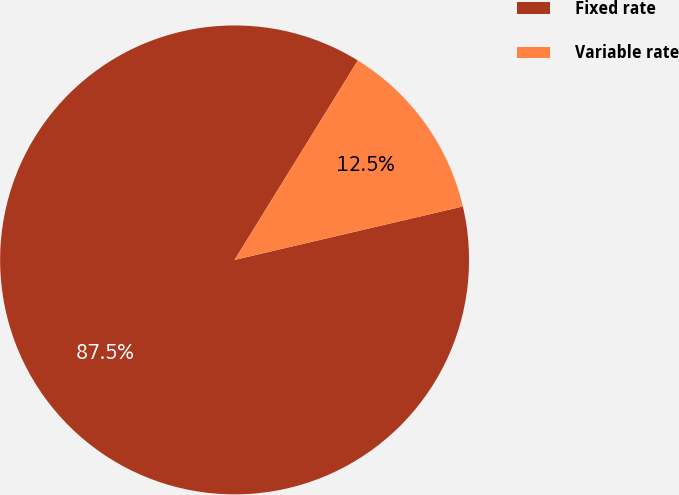Convert chart. <chart><loc_0><loc_0><loc_500><loc_500><pie_chart><fcel>Fixed rate<fcel>Variable rate<nl><fcel>87.47%<fcel>12.53%<nl></chart> 